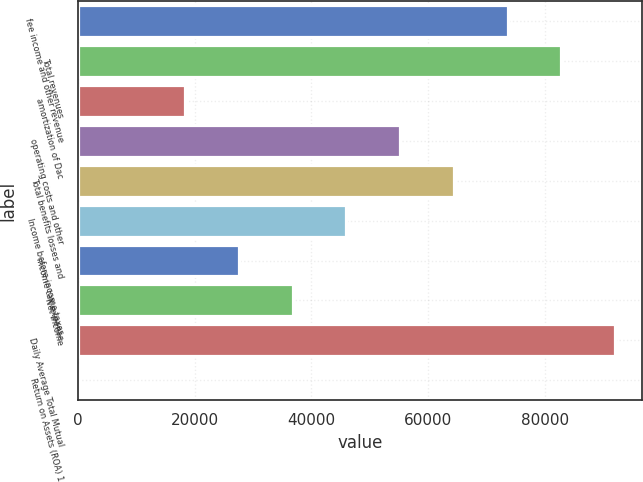<chart> <loc_0><loc_0><loc_500><loc_500><bar_chart><fcel>fee income and other revenue<fcel>Total revenues<fcel>amortization of Dac<fcel>operating costs and other<fcel>Total benefits losses and<fcel>Income before income taxes<fcel>income tax expense<fcel>Net income<fcel>Daily Average Total Mutual<fcel>Return on Assets (ROA) 1<nl><fcel>73635.3<fcel>82838.6<fcel>18415.2<fcel>55228.6<fcel>64431.9<fcel>46025.2<fcel>27618.5<fcel>36821.9<fcel>92042<fcel>8.5<nl></chart> 